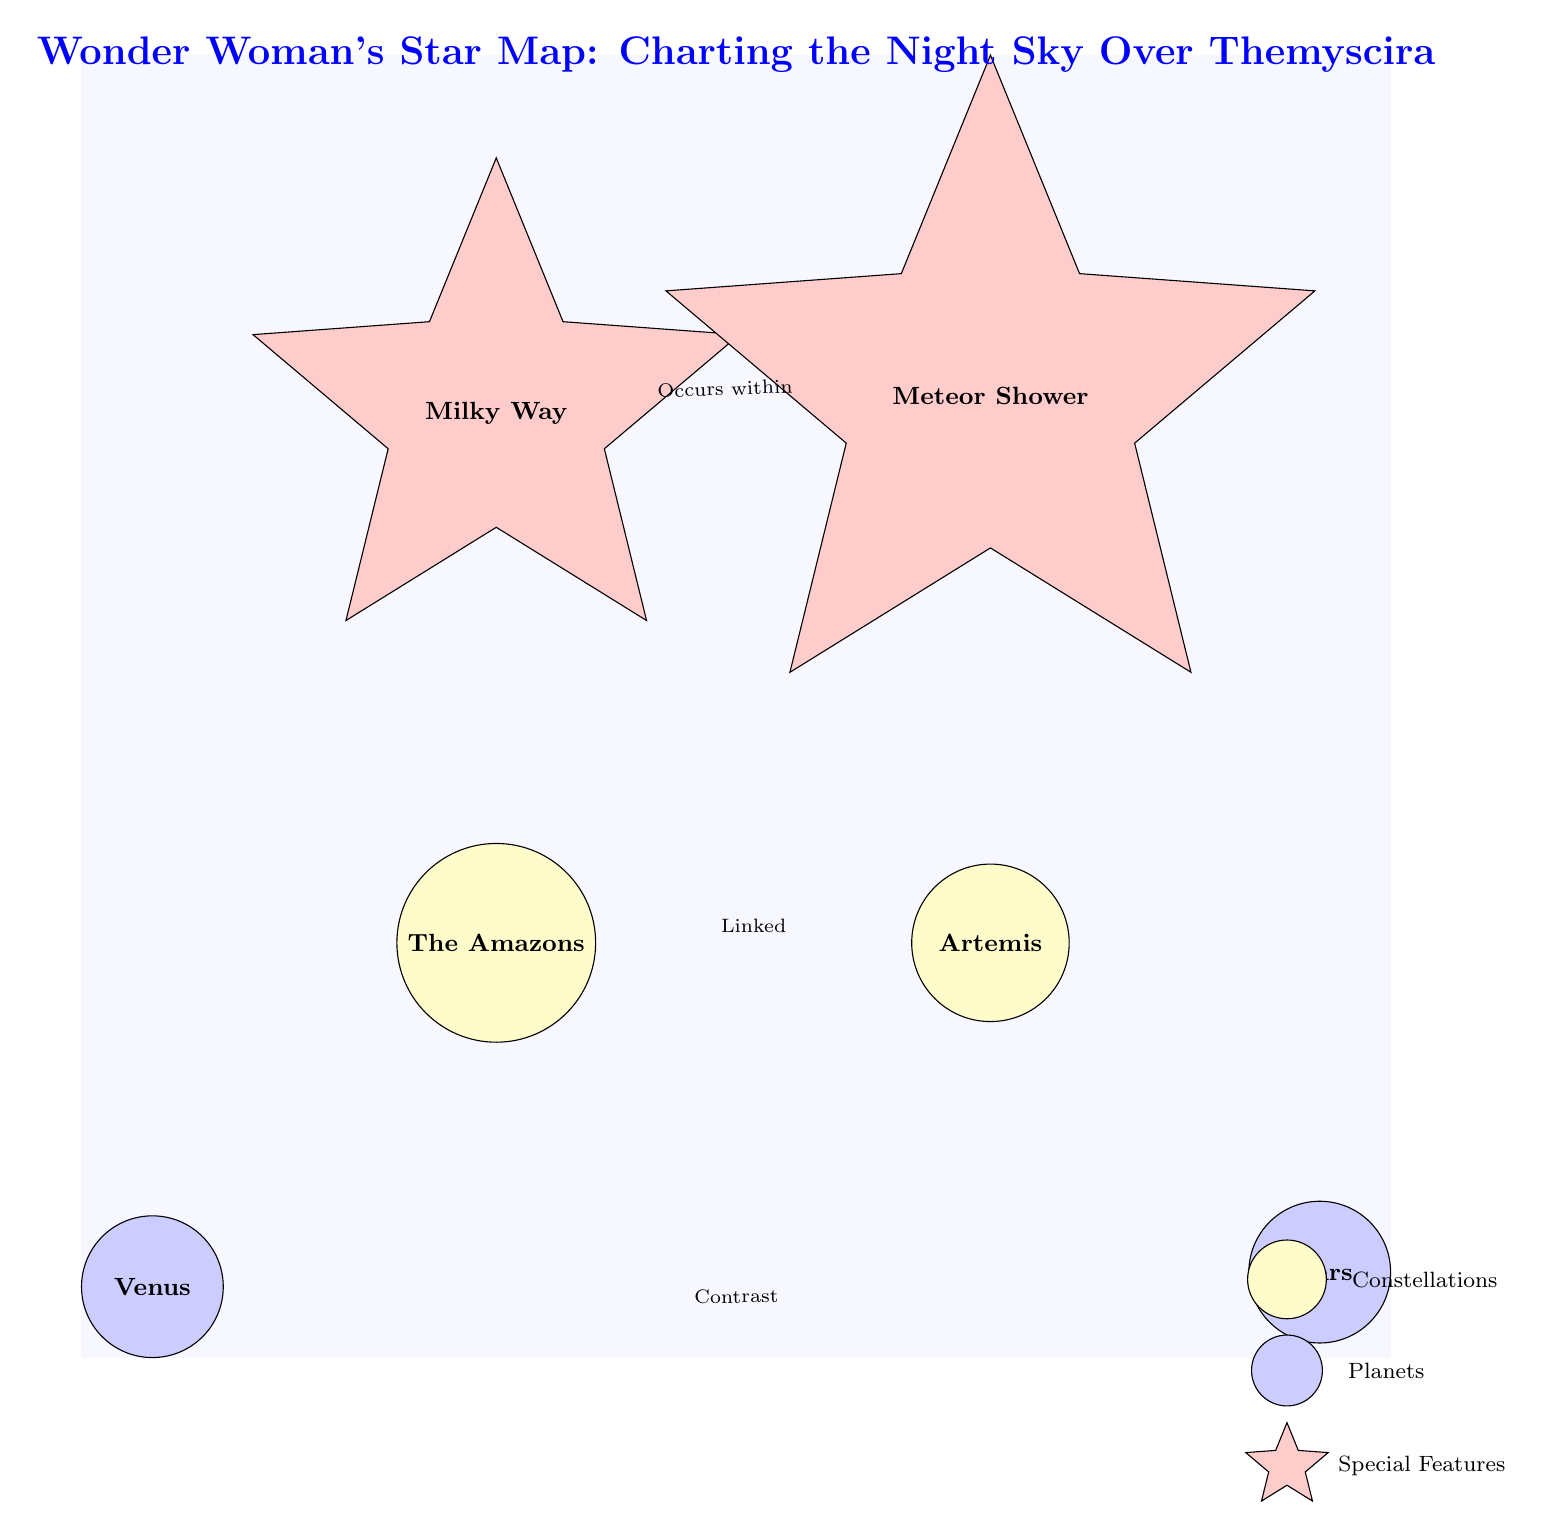What is the name of the constellation linked to Artemis? The diagram shows a direct connection (link) between the Amazons and Artemis labeled "Linked," which indicates that the constellation linked to Artemis is the Amazons.
Answer: The Amazons How many planets are represented in the diagram? Examining the diagram, there are two planets shown: Venus and Mars. Counting them gives a total of two planets in the diagram.
Answer: 2 What feature occurs within the Milky Way? The diagram states that the meteor shower "Occurs within" the Milky Way, indicating that the meteor shower is the feature associated with the Milky Way.
Answer: Meteor Shower Which planet is contrasted with Venus? The diagram's link indicates a relationship labeled "Contrast" with Venus, which connects to Mars. Therefore, the planet contrasted with Venus is Mars.
Answer: Mars What color is used to represent the constellations? In the diagram, constellations (like The Amazons and Artemis) are represented with a yellow fill color. Thus, the answer regarding the color of the constellations is yellow.
Answer: Yellow Which special feature is shown above Artemis? The diagram indicates that there is a special feature directly above Artemis labeled as "Meteor Shower." Hence, the special feature above Artemis is a meteor shower.
Answer: Meteor Shower What relationship exists between Venus and Mars? The diagram illustrates a link labeled "Contrast" between the nodes Venus and Mars, indicating a contrasting relationship exists between the two planets.
Answer: Contrast What graphical elements are used for planets in the diagram? In the diagram, planets (like Venus and Mars) are denoted with circular shapes filled with blue, signifying that circular elements represent planets.
Answer: Circle What celestial body is at the top of the diagram? The diagram illustrates the Milky Way positioned above the Amazons, indicating that the celestial body at the top is the Milky Way.
Answer: Milky Way 